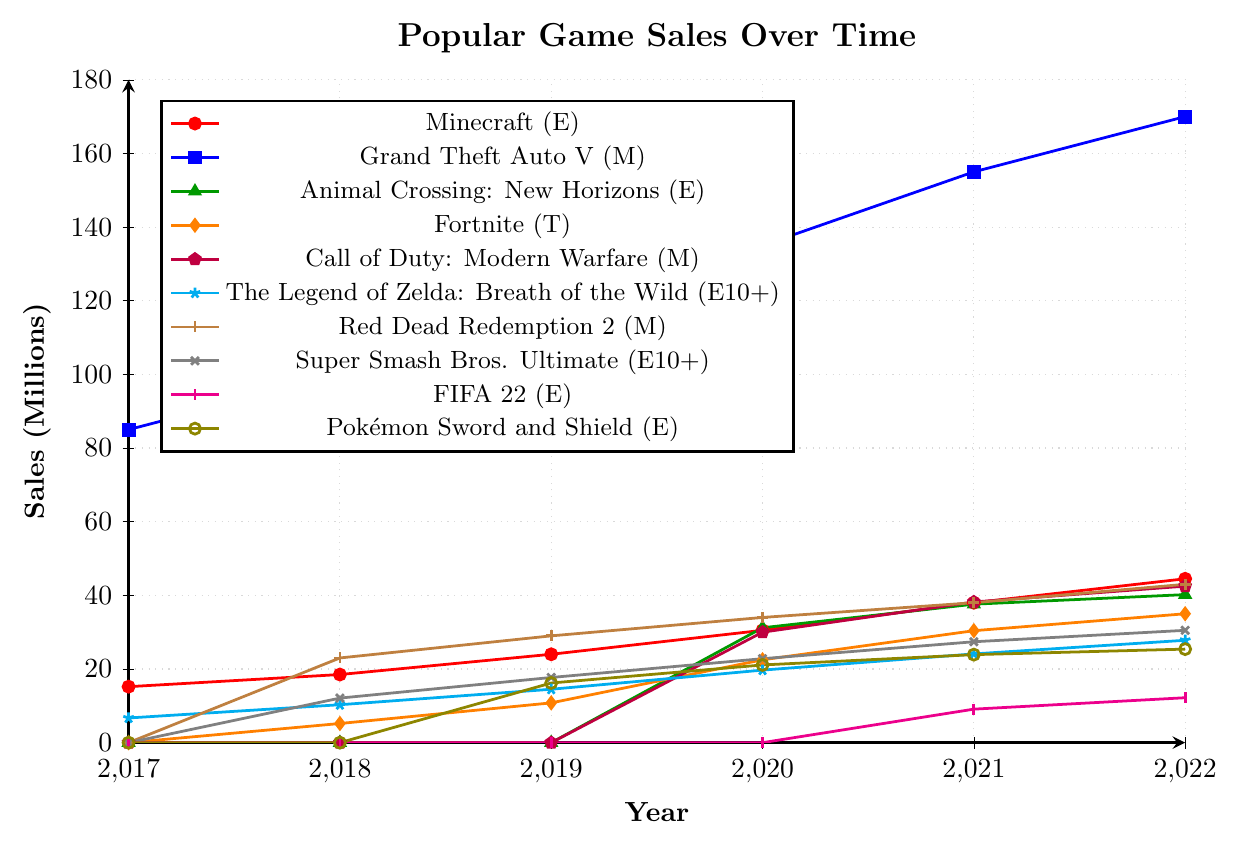Which game had the highest sales in 2022? Look at the sales for each game in 2022. Grand Theft Auto V had 170 million sales, which is the highest in that year.
Answer: Grand Theft Auto V What is the total sales for Minecraft from 2017 to 2022? Sum the sales figures for Minecraft from each year: 15.2 (2017) + 18.5 (2018) + 24.0 (2019) + 30.5 (2020) + 38.0 (2021) + 44.5 (2022) = 170.7 million.
Answer: 170.7 million Compare the sales of Animal Crossing: New Horizons in 2020 and 2022. How much did it increase? Find the sales for Animal Crossing: New Horizons in 2020 and 2022. The sales in 2020 were 31.2 million and in 2022 were 40.2 million. The increase is 40.2 - 31.2 = 9.0 million.
Answer: 9.0 million Which game had no sales in 2019 but a significant increase in the following years? Identify the games with zero sales in 2019 and check if their sales increased significantly in the following years. Call of Duty: Modern Warfare had no sales in 2019 but 30.0 million in 2020 and 42.5 million in 2022.
Answer: Call of Duty: Modern Warfare What is the average annual sales growth for Fortnite from 2018 to 2022? Calculate the difference in sales between each consecutive year and then find the average. (10.8 - 5.2) + (22.5 - 10.8) + (30.4 - 22.5) + (35.0 - 30.4) = 5.6 + 11.7 + 7.9 + 4.6 = 29.8, then divide by the number of intervals (4). 29.8 / 4 = 7.45 million per year.
Answer: 7.45 million per year Which game's sales plateaued between 2021 and 2022? Check the sales figures for each game in 2021 and 2022 to see which has little to no change. Red Dead Redemption 2 shows a plateau with 38.0 million in 2021 and 43.0 million in 2022.
Answer: Red Dead Redemption 2 What were the combined sales of Pokémon Sword and Shield and FIFA 22 in 2022? Add the sales figures for Pokémon Sword and Shield (25.4 million) and FIFA 22 (12.2 million) for 2022. 25.4 + 12.2 = 37.6 million.
Answer: 37.6 million Which game with an E or E10+ rating saw the highest total sales by 2022? Compare the total sales by summing sales figures from 2017 to 2022 for games with E or E10+ ratings. Minecraft's total is 170.7 million, which is higher than the others.
Answer: Minecraft What is the trend of Grand Theft Auto V sales from 2017 to 2022? Observe the sales figures of Grand Theft Auto V over these years: 85.0 (2017), 100.0 (2018), 115.0 (2019), 135.0 (2020), 155.0 (2021), and 170.0 (2022). The trend shows a steady increase.
Answer: Steady increase By how much did sales of The Legend of Zelda: Breath of the Wild increase from 2017 to 2022? Calculate the difference in sales from 2017 (6.7 million) to 2022 (27.8 million). 27.8 - 6.7 = 21.1 million.
Answer: 21.1 million 